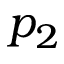<formula> <loc_0><loc_0><loc_500><loc_500>p _ { 2 }</formula> 